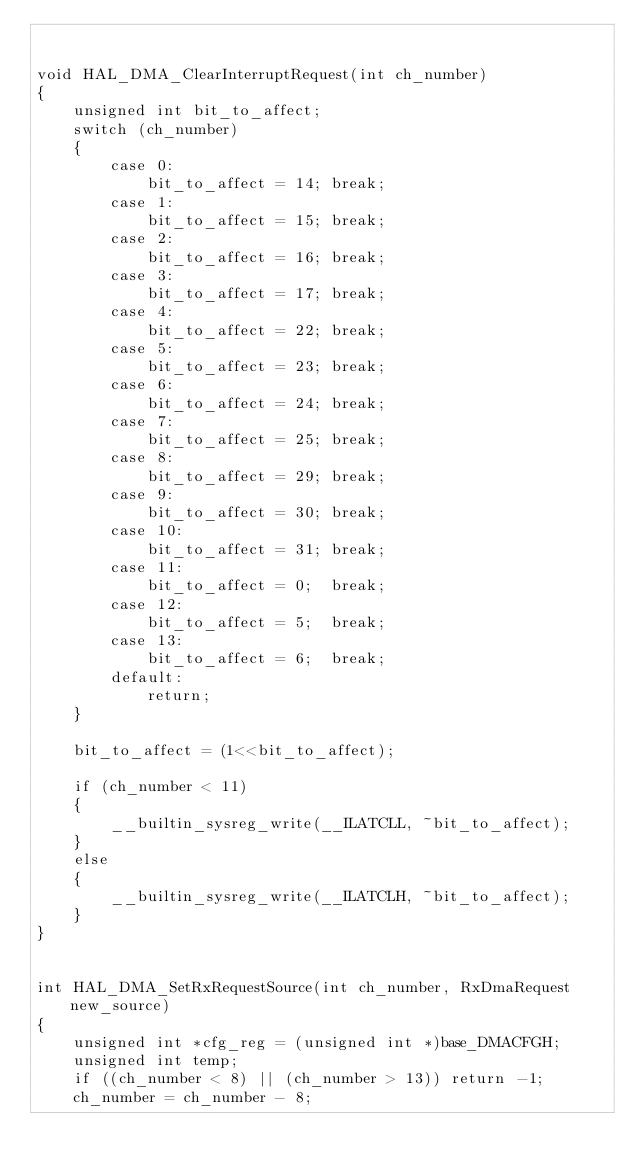Convert code to text. <code><loc_0><loc_0><loc_500><loc_500><_C_>

void HAL_DMA_ClearInterruptRequest(int ch_number)
{
	unsigned int bit_to_affect;
	switch (ch_number)
	{
		case 0:
			bit_to_affect = 14;	break;
		case 1: 
			bit_to_affect = 15;	break;
		case 2: 
			bit_to_affect = 16;	break;
		case 3: 
			bit_to_affect = 17;	break;
		case 4:
			bit_to_affect = 22;	break;
		case 5:
			bit_to_affect = 23;	break;
		case 6:
			bit_to_affect = 24;	break;
		case 7:
			bit_to_affect = 25;	break;
		case 8:
			bit_to_affect = 29;	break;
		case 9:
			bit_to_affect = 30;	break;
		case 10:
			bit_to_affect = 31;	break;
		case 11:
			bit_to_affect = 0;	break;
		case 12:
			bit_to_affect = 5;	break;
		case 13:		
			bit_to_affect = 6;	break;
		default:
			return;
	}
	
	bit_to_affect = (1<<bit_to_affect);
	
	if (ch_number < 11)
	{
		__builtin_sysreg_write(__ILATCLL, ~bit_to_affect);
	}
	else
	{
		__builtin_sysreg_write(__ILATCLH, ~bit_to_affect);
	}
}


int HAL_DMA_SetRxRequestSource(int ch_number, RxDmaRequest new_source)
{
	unsigned int *cfg_reg = (unsigned int *)base_DMACFGH;
	unsigned int temp;
	if ((ch_number < 8) || (ch_number > 13)) return -1;
	ch_number = ch_number - 8;</code> 